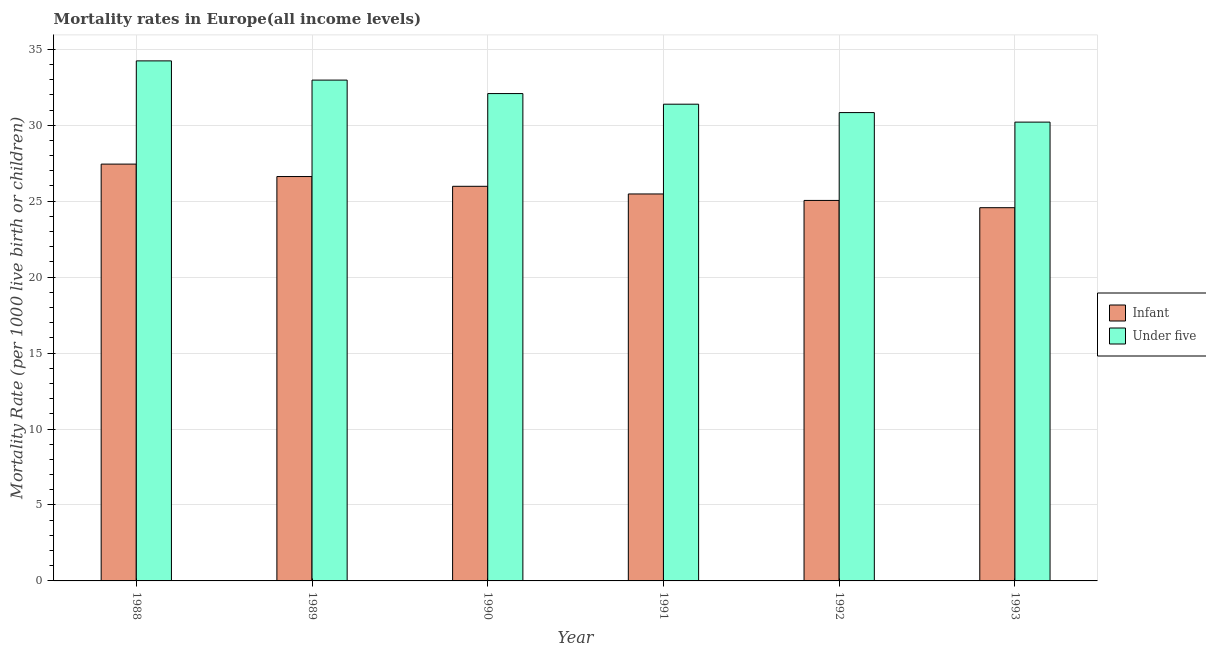Are the number of bars on each tick of the X-axis equal?
Give a very brief answer. Yes. How many bars are there on the 3rd tick from the right?
Ensure brevity in your answer.  2. What is the label of the 6th group of bars from the left?
Give a very brief answer. 1993. In how many cases, is the number of bars for a given year not equal to the number of legend labels?
Offer a terse response. 0. What is the under-5 mortality rate in 1993?
Keep it short and to the point. 30.21. Across all years, what is the maximum under-5 mortality rate?
Provide a succinct answer. 34.24. Across all years, what is the minimum under-5 mortality rate?
Provide a short and direct response. 30.21. What is the total under-5 mortality rate in the graph?
Provide a short and direct response. 191.72. What is the difference between the under-5 mortality rate in 1988 and that in 1992?
Make the answer very short. 3.4. What is the difference between the infant mortality rate in 1991 and the under-5 mortality rate in 1993?
Provide a succinct answer. 0.9. What is the average infant mortality rate per year?
Offer a very short reply. 25.86. What is the ratio of the under-5 mortality rate in 1991 to that in 1992?
Make the answer very short. 1.02. Is the difference between the infant mortality rate in 1989 and 1992 greater than the difference between the under-5 mortality rate in 1989 and 1992?
Offer a terse response. No. What is the difference between the highest and the second highest under-5 mortality rate?
Provide a succinct answer. 1.27. What is the difference between the highest and the lowest infant mortality rate?
Offer a very short reply. 2.87. What does the 1st bar from the left in 1992 represents?
Make the answer very short. Infant. What does the 1st bar from the right in 1988 represents?
Your response must be concise. Under five. Are all the bars in the graph horizontal?
Your answer should be very brief. No. How many years are there in the graph?
Your response must be concise. 6. Are the values on the major ticks of Y-axis written in scientific E-notation?
Offer a very short reply. No. Does the graph contain any zero values?
Your response must be concise. No. Where does the legend appear in the graph?
Make the answer very short. Center right. How many legend labels are there?
Offer a terse response. 2. What is the title of the graph?
Keep it short and to the point. Mortality rates in Europe(all income levels). What is the label or title of the X-axis?
Offer a terse response. Year. What is the label or title of the Y-axis?
Give a very brief answer. Mortality Rate (per 1000 live birth or children). What is the Mortality Rate (per 1000 live birth or children) in Infant in 1988?
Provide a succinct answer. 27.44. What is the Mortality Rate (per 1000 live birth or children) in Under five in 1988?
Offer a very short reply. 34.24. What is the Mortality Rate (per 1000 live birth or children) of Infant in 1989?
Make the answer very short. 26.62. What is the Mortality Rate (per 1000 live birth or children) in Under five in 1989?
Offer a very short reply. 32.97. What is the Mortality Rate (per 1000 live birth or children) of Infant in 1990?
Provide a succinct answer. 25.98. What is the Mortality Rate (per 1000 live birth or children) in Under five in 1990?
Your answer should be very brief. 32.08. What is the Mortality Rate (per 1000 live birth or children) in Infant in 1991?
Keep it short and to the point. 25.48. What is the Mortality Rate (per 1000 live birth or children) in Under five in 1991?
Your response must be concise. 31.39. What is the Mortality Rate (per 1000 live birth or children) in Infant in 1992?
Ensure brevity in your answer.  25.05. What is the Mortality Rate (per 1000 live birth or children) of Under five in 1992?
Provide a short and direct response. 30.83. What is the Mortality Rate (per 1000 live birth or children) of Infant in 1993?
Provide a succinct answer. 24.57. What is the Mortality Rate (per 1000 live birth or children) in Under five in 1993?
Keep it short and to the point. 30.21. Across all years, what is the maximum Mortality Rate (per 1000 live birth or children) of Infant?
Your answer should be very brief. 27.44. Across all years, what is the maximum Mortality Rate (per 1000 live birth or children) of Under five?
Ensure brevity in your answer.  34.24. Across all years, what is the minimum Mortality Rate (per 1000 live birth or children) of Infant?
Your answer should be very brief. 24.57. Across all years, what is the minimum Mortality Rate (per 1000 live birth or children) in Under five?
Your answer should be very brief. 30.21. What is the total Mortality Rate (per 1000 live birth or children) in Infant in the graph?
Offer a very short reply. 155.14. What is the total Mortality Rate (per 1000 live birth or children) in Under five in the graph?
Ensure brevity in your answer.  191.72. What is the difference between the Mortality Rate (per 1000 live birth or children) of Infant in 1988 and that in 1989?
Your answer should be compact. 0.82. What is the difference between the Mortality Rate (per 1000 live birth or children) in Under five in 1988 and that in 1989?
Ensure brevity in your answer.  1.27. What is the difference between the Mortality Rate (per 1000 live birth or children) of Infant in 1988 and that in 1990?
Your answer should be very brief. 1.46. What is the difference between the Mortality Rate (per 1000 live birth or children) of Under five in 1988 and that in 1990?
Your answer should be very brief. 2.15. What is the difference between the Mortality Rate (per 1000 live birth or children) in Infant in 1988 and that in 1991?
Your response must be concise. 1.97. What is the difference between the Mortality Rate (per 1000 live birth or children) of Under five in 1988 and that in 1991?
Provide a succinct answer. 2.85. What is the difference between the Mortality Rate (per 1000 live birth or children) of Infant in 1988 and that in 1992?
Offer a terse response. 2.39. What is the difference between the Mortality Rate (per 1000 live birth or children) of Under five in 1988 and that in 1992?
Your answer should be compact. 3.4. What is the difference between the Mortality Rate (per 1000 live birth or children) in Infant in 1988 and that in 1993?
Ensure brevity in your answer.  2.87. What is the difference between the Mortality Rate (per 1000 live birth or children) of Under five in 1988 and that in 1993?
Give a very brief answer. 4.03. What is the difference between the Mortality Rate (per 1000 live birth or children) in Infant in 1989 and that in 1990?
Provide a short and direct response. 0.64. What is the difference between the Mortality Rate (per 1000 live birth or children) in Under five in 1989 and that in 1990?
Make the answer very short. 0.89. What is the difference between the Mortality Rate (per 1000 live birth or children) in Infant in 1989 and that in 1991?
Provide a succinct answer. 1.15. What is the difference between the Mortality Rate (per 1000 live birth or children) in Under five in 1989 and that in 1991?
Your answer should be very brief. 1.59. What is the difference between the Mortality Rate (per 1000 live birth or children) in Infant in 1989 and that in 1992?
Provide a short and direct response. 1.57. What is the difference between the Mortality Rate (per 1000 live birth or children) of Under five in 1989 and that in 1992?
Ensure brevity in your answer.  2.14. What is the difference between the Mortality Rate (per 1000 live birth or children) in Infant in 1989 and that in 1993?
Make the answer very short. 2.05. What is the difference between the Mortality Rate (per 1000 live birth or children) in Under five in 1989 and that in 1993?
Provide a short and direct response. 2.77. What is the difference between the Mortality Rate (per 1000 live birth or children) in Infant in 1990 and that in 1991?
Keep it short and to the point. 0.5. What is the difference between the Mortality Rate (per 1000 live birth or children) of Under five in 1990 and that in 1991?
Offer a very short reply. 0.7. What is the difference between the Mortality Rate (per 1000 live birth or children) of Infant in 1990 and that in 1992?
Give a very brief answer. 0.93. What is the difference between the Mortality Rate (per 1000 live birth or children) of Under five in 1990 and that in 1992?
Provide a short and direct response. 1.25. What is the difference between the Mortality Rate (per 1000 live birth or children) in Infant in 1990 and that in 1993?
Your answer should be compact. 1.41. What is the difference between the Mortality Rate (per 1000 live birth or children) of Under five in 1990 and that in 1993?
Your answer should be compact. 1.88. What is the difference between the Mortality Rate (per 1000 live birth or children) in Infant in 1991 and that in 1992?
Offer a terse response. 0.43. What is the difference between the Mortality Rate (per 1000 live birth or children) in Under five in 1991 and that in 1992?
Your response must be concise. 0.55. What is the difference between the Mortality Rate (per 1000 live birth or children) of Infant in 1991 and that in 1993?
Make the answer very short. 0.9. What is the difference between the Mortality Rate (per 1000 live birth or children) of Under five in 1991 and that in 1993?
Offer a terse response. 1.18. What is the difference between the Mortality Rate (per 1000 live birth or children) in Infant in 1992 and that in 1993?
Keep it short and to the point. 0.48. What is the difference between the Mortality Rate (per 1000 live birth or children) in Under five in 1992 and that in 1993?
Your answer should be compact. 0.63. What is the difference between the Mortality Rate (per 1000 live birth or children) in Infant in 1988 and the Mortality Rate (per 1000 live birth or children) in Under five in 1989?
Offer a terse response. -5.53. What is the difference between the Mortality Rate (per 1000 live birth or children) of Infant in 1988 and the Mortality Rate (per 1000 live birth or children) of Under five in 1990?
Your response must be concise. -4.64. What is the difference between the Mortality Rate (per 1000 live birth or children) in Infant in 1988 and the Mortality Rate (per 1000 live birth or children) in Under five in 1991?
Make the answer very short. -3.94. What is the difference between the Mortality Rate (per 1000 live birth or children) in Infant in 1988 and the Mortality Rate (per 1000 live birth or children) in Under five in 1992?
Provide a short and direct response. -3.39. What is the difference between the Mortality Rate (per 1000 live birth or children) of Infant in 1988 and the Mortality Rate (per 1000 live birth or children) of Under five in 1993?
Provide a short and direct response. -2.76. What is the difference between the Mortality Rate (per 1000 live birth or children) of Infant in 1989 and the Mortality Rate (per 1000 live birth or children) of Under five in 1990?
Your answer should be very brief. -5.46. What is the difference between the Mortality Rate (per 1000 live birth or children) of Infant in 1989 and the Mortality Rate (per 1000 live birth or children) of Under five in 1991?
Make the answer very short. -4.76. What is the difference between the Mortality Rate (per 1000 live birth or children) of Infant in 1989 and the Mortality Rate (per 1000 live birth or children) of Under five in 1992?
Your response must be concise. -4.21. What is the difference between the Mortality Rate (per 1000 live birth or children) of Infant in 1989 and the Mortality Rate (per 1000 live birth or children) of Under five in 1993?
Offer a terse response. -3.58. What is the difference between the Mortality Rate (per 1000 live birth or children) of Infant in 1990 and the Mortality Rate (per 1000 live birth or children) of Under five in 1991?
Provide a succinct answer. -5.41. What is the difference between the Mortality Rate (per 1000 live birth or children) of Infant in 1990 and the Mortality Rate (per 1000 live birth or children) of Under five in 1992?
Provide a succinct answer. -4.85. What is the difference between the Mortality Rate (per 1000 live birth or children) of Infant in 1990 and the Mortality Rate (per 1000 live birth or children) of Under five in 1993?
Make the answer very short. -4.23. What is the difference between the Mortality Rate (per 1000 live birth or children) in Infant in 1991 and the Mortality Rate (per 1000 live birth or children) in Under five in 1992?
Give a very brief answer. -5.36. What is the difference between the Mortality Rate (per 1000 live birth or children) of Infant in 1991 and the Mortality Rate (per 1000 live birth or children) of Under five in 1993?
Provide a succinct answer. -4.73. What is the difference between the Mortality Rate (per 1000 live birth or children) in Infant in 1992 and the Mortality Rate (per 1000 live birth or children) in Under five in 1993?
Ensure brevity in your answer.  -5.16. What is the average Mortality Rate (per 1000 live birth or children) in Infant per year?
Offer a terse response. 25.86. What is the average Mortality Rate (per 1000 live birth or children) of Under five per year?
Offer a very short reply. 31.95. In the year 1988, what is the difference between the Mortality Rate (per 1000 live birth or children) in Infant and Mortality Rate (per 1000 live birth or children) in Under five?
Your response must be concise. -6.8. In the year 1989, what is the difference between the Mortality Rate (per 1000 live birth or children) of Infant and Mortality Rate (per 1000 live birth or children) of Under five?
Your answer should be compact. -6.35. In the year 1990, what is the difference between the Mortality Rate (per 1000 live birth or children) in Infant and Mortality Rate (per 1000 live birth or children) in Under five?
Keep it short and to the point. -6.11. In the year 1991, what is the difference between the Mortality Rate (per 1000 live birth or children) of Infant and Mortality Rate (per 1000 live birth or children) of Under five?
Your answer should be very brief. -5.91. In the year 1992, what is the difference between the Mortality Rate (per 1000 live birth or children) in Infant and Mortality Rate (per 1000 live birth or children) in Under five?
Ensure brevity in your answer.  -5.78. In the year 1993, what is the difference between the Mortality Rate (per 1000 live birth or children) of Infant and Mortality Rate (per 1000 live birth or children) of Under five?
Your response must be concise. -5.63. What is the ratio of the Mortality Rate (per 1000 live birth or children) in Infant in 1988 to that in 1989?
Provide a short and direct response. 1.03. What is the ratio of the Mortality Rate (per 1000 live birth or children) in Under five in 1988 to that in 1989?
Your response must be concise. 1.04. What is the ratio of the Mortality Rate (per 1000 live birth or children) in Infant in 1988 to that in 1990?
Provide a short and direct response. 1.06. What is the ratio of the Mortality Rate (per 1000 live birth or children) of Under five in 1988 to that in 1990?
Your response must be concise. 1.07. What is the ratio of the Mortality Rate (per 1000 live birth or children) of Infant in 1988 to that in 1991?
Keep it short and to the point. 1.08. What is the ratio of the Mortality Rate (per 1000 live birth or children) in Under five in 1988 to that in 1991?
Make the answer very short. 1.09. What is the ratio of the Mortality Rate (per 1000 live birth or children) in Infant in 1988 to that in 1992?
Keep it short and to the point. 1.1. What is the ratio of the Mortality Rate (per 1000 live birth or children) in Under five in 1988 to that in 1992?
Ensure brevity in your answer.  1.11. What is the ratio of the Mortality Rate (per 1000 live birth or children) in Infant in 1988 to that in 1993?
Provide a short and direct response. 1.12. What is the ratio of the Mortality Rate (per 1000 live birth or children) in Under five in 1988 to that in 1993?
Keep it short and to the point. 1.13. What is the ratio of the Mortality Rate (per 1000 live birth or children) in Infant in 1989 to that in 1990?
Keep it short and to the point. 1.02. What is the ratio of the Mortality Rate (per 1000 live birth or children) of Under five in 1989 to that in 1990?
Provide a short and direct response. 1.03. What is the ratio of the Mortality Rate (per 1000 live birth or children) of Infant in 1989 to that in 1991?
Keep it short and to the point. 1.04. What is the ratio of the Mortality Rate (per 1000 live birth or children) of Under five in 1989 to that in 1991?
Offer a very short reply. 1.05. What is the ratio of the Mortality Rate (per 1000 live birth or children) of Infant in 1989 to that in 1992?
Provide a short and direct response. 1.06. What is the ratio of the Mortality Rate (per 1000 live birth or children) in Under five in 1989 to that in 1992?
Keep it short and to the point. 1.07. What is the ratio of the Mortality Rate (per 1000 live birth or children) of Infant in 1989 to that in 1993?
Your answer should be compact. 1.08. What is the ratio of the Mortality Rate (per 1000 live birth or children) in Under five in 1989 to that in 1993?
Provide a short and direct response. 1.09. What is the ratio of the Mortality Rate (per 1000 live birth or children) of Infant in 1990 to that in 1991?
Your answer should be very brief. 1.02. What is the ratio of the Mortality Rate (per 1000 live birth or children) of Under five in 1990 to that in 1991?
Your response must be concise. 1.02. What is the ratio of the Mortality Rate (per 1000 live birth or children) of Infant in 1990 to that in 1992?
Your answer should be compact. 1.04. What is the ratio of the Mortality Rate (per 1000 live birth or children) in Under five in 1990 to that in 1992?
Keep it short and to the point. 1.04. What is the ratio of the Mortality Rate (per 1000 live birth or children) of Infant in 1990 to that in 1993?
Ensure brevity in your answer.  1.06. What is the ratio of the Mortality Rate (per 1000 live birth or children) of Under five in 1990 to that in 1993?
Give a very brief answer. 1.06. What is the ratio of the Mortality Rate (per 1000 live birth or children) in Infant in 1991 to that in 1992?
Your answer should be compact. 1.02. What is the ratio of the Mortality Rate (per 1000 live birth or children) of Under five in 1991 to that in 1992?
Offer a terse response. 1.02. What is the ratio of the Mortality Rate (per 1000 live birth or children) of Infant in 1991 to that in 1993?
Make the answer very short. 1.04. What is the ratio of the Mortality Rate (per 1000 live birth or children) in Under five in 1991 to that in 1993?
Give a very brief answer. 1.04. What is the ratio of the Mortality Rate (per 1000 live birth or children) in Infant in 1992 to that in 1993?
Offer a terse response. 1.02. What is the ratio of the Mortality Rate (per 1000 live birth or children) of Under five in 1992 to that in 1993?
Make the answer very short. 1.02. What is the difference between the highest and the second highest Mortality Rate (per 1000 live birth or children) of Infant?
Offer a very short reply. 0.82. What is the difference between the highest and the second highest Mortality Rate (per 1000 live birth or children) of Under five?
Your answer should be very brief. 1.27. What is the difference between the highest and the lowest Mortality Rate (per 1000 live birth or children) of Infant?
Make the answer very short. 2.87. What is the difference between the highest and the lowest Mortality Rate (per 1000 live birth or children) in Under five?
Make the answer very short. 4.03. 